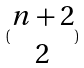Convert formula to latex. <formula><loc_0><loc_0><loc_500><loc_500>( \begin{matrix} n + 2 \\ 2 \end{matrix} )</formula> 